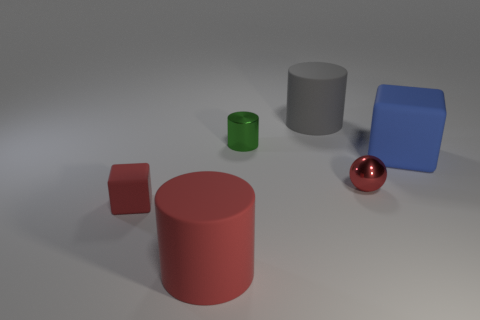Add 3 matte spheres. How many objects exist? 9 Subtract all spheres. How many objects are left? 5 Subtract all large red matte objects. Subtract all cylinders. How many objects are left? 2 Add 6 shiny spheres. How many shiny spheres are left? 7 Add 1 big matte cylinders. How many big matte cylinders exist? 3 Subtract 0 brown spheres. How many objects are left? 6 